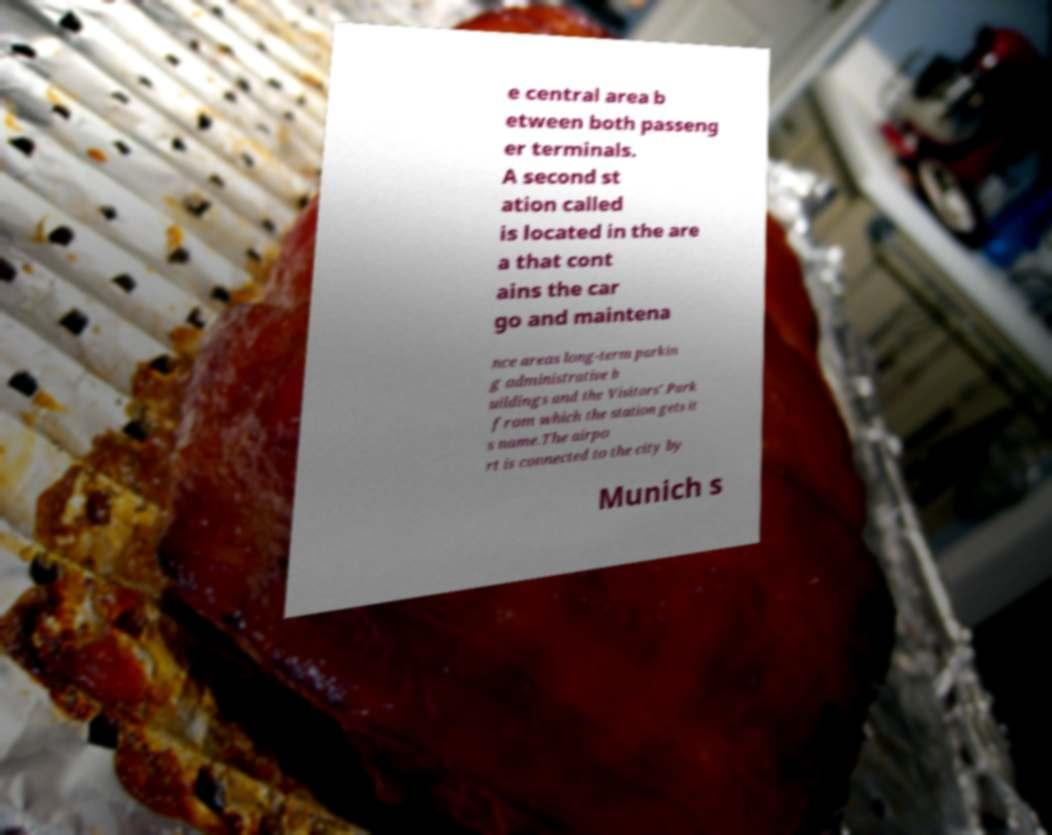Could you extract and type out the text from this image? e central area b etween both passeng er terminals. A second st ation called is located in the are a that cont ains the car go and maintena nce areas long-term parkin g administrative b uildings and the Visitors' Park from which the station gets it s name.The airpo rt is connected to the city by Munich s 